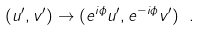Convert formula to latex. <formula><loc_0><loc_0><loc_500><loc_500>( u ^ { \prime } , v ^ { \prime } ) \rightarrow ( e ^ { i \phi } u ^ { \prime } , e ^ { - i \phi } v ^ { \prime } ) \ .</formula> 